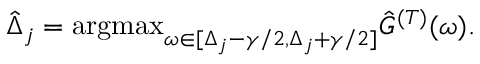Convert formula to latex. <formula><loc_0><loc_0><loc_500><loc_500>\hat { \Delta } _ { j } = \arg \max _ { \omega \in [ \Delta _ { j } - \gamma / 2 , \Delta _ { j } + \gamma / 2 ] } \hat { G } ^ { ( T ) } ( \omega ) .</formula> 